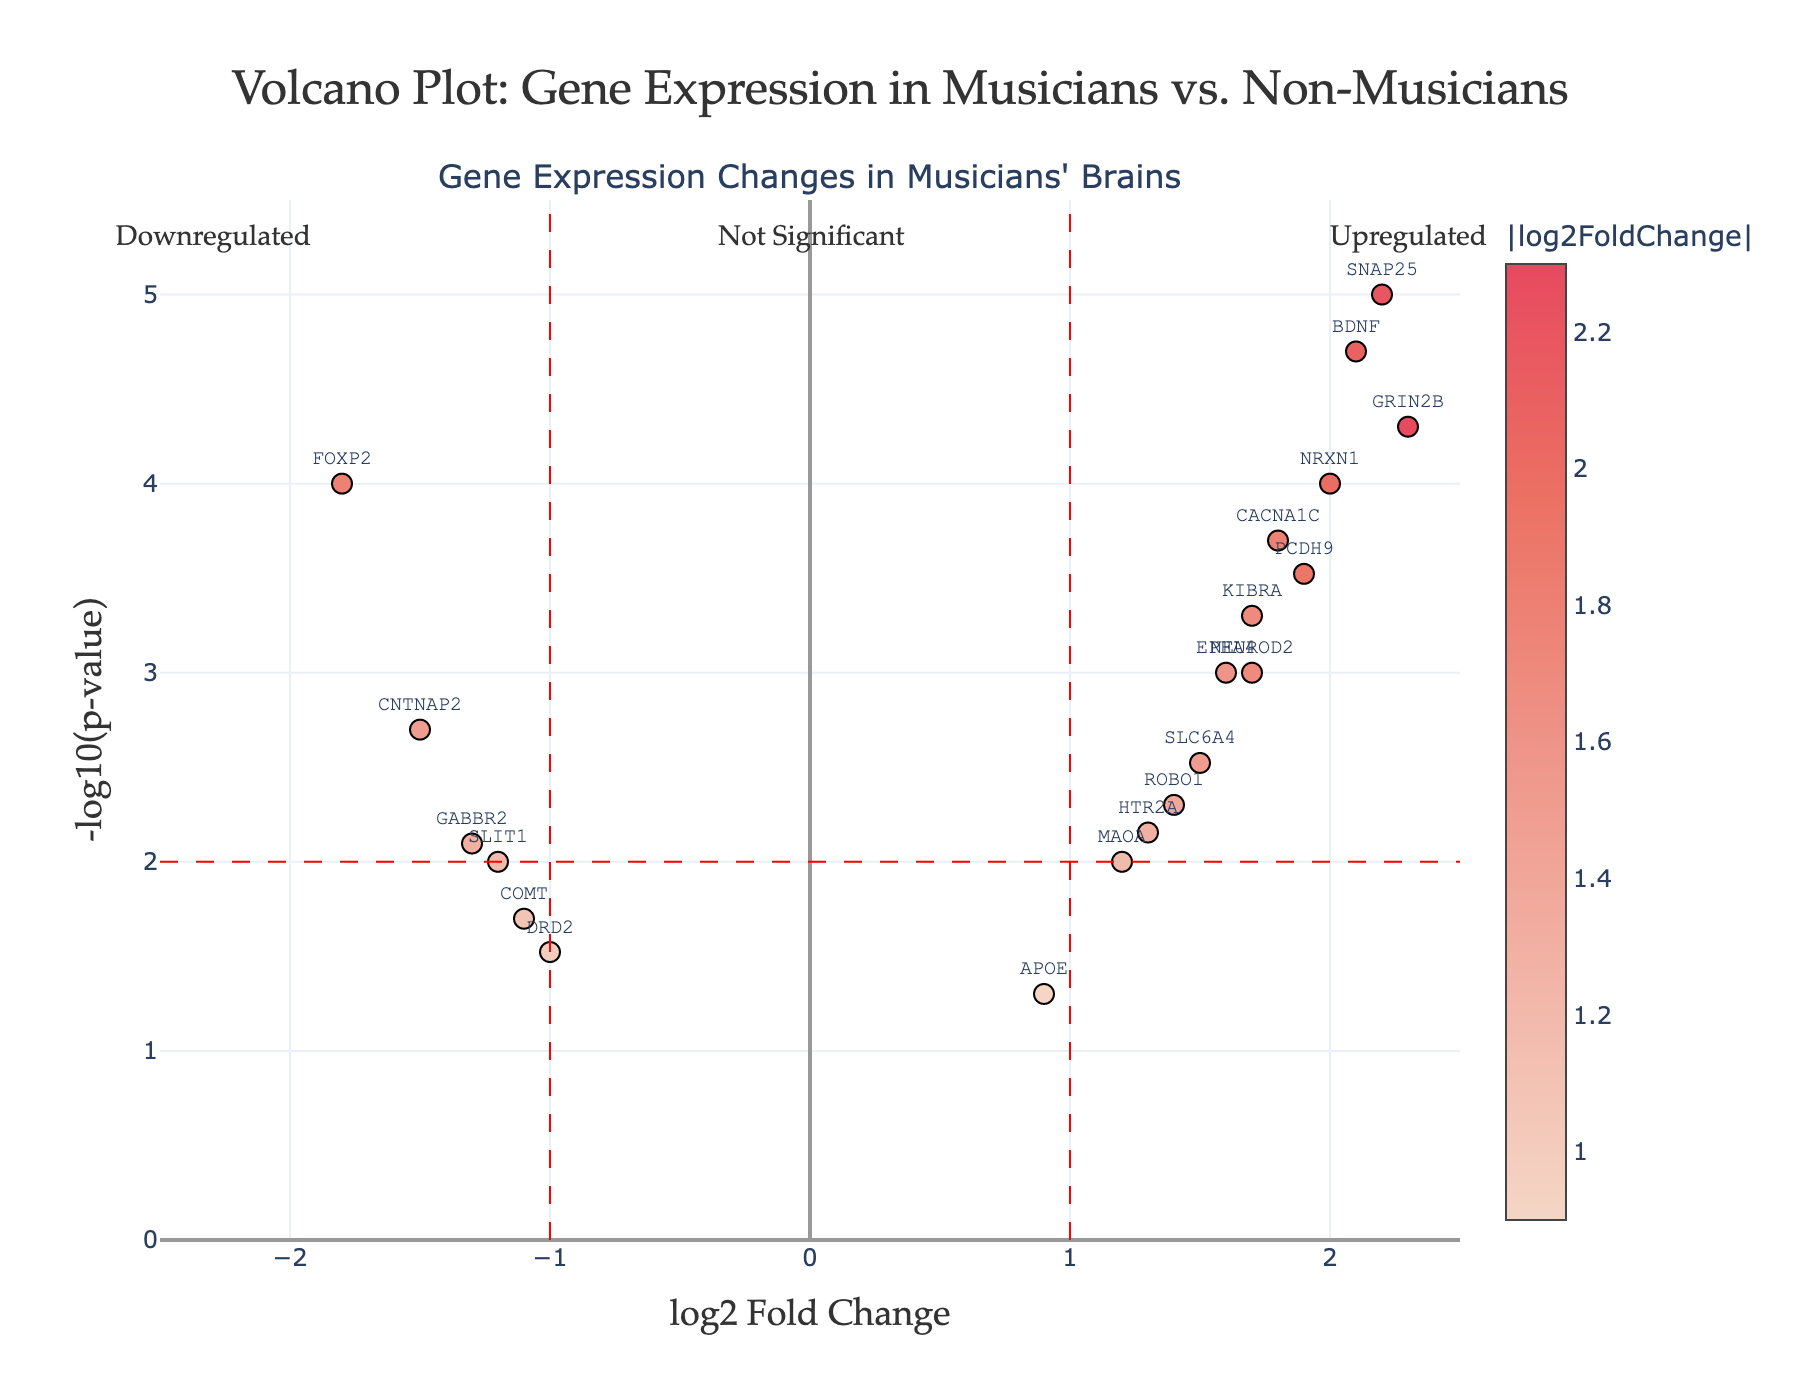How many genes have a log2 fold change greater than 2? To identify genes with a log2 fold change greater than 2, we look at the x-axis values and check for points beyond 2. The genes fitting this criterion are GRIN2B, BDNF, NRXN1, and SNAP25, so there are 4 such genes.
Answer: 4 Which gene has the highest -log10(p-value)? To find the gene with the highest -log10(p-value), we look for the point with the highest y-axis value. The highest point corresponds to the gene GRIN2B.
Answer: GRIN2B How many genes are upregulated (positive log2 fold change) and also statistically significant (p-value < 0.05)? To identify these genes, we look for points to the right of zero on the x-axis (indicating upregulation) and above the horizontal red dashed line at y=2 (-log10(0.05)). These genes are GRIN2B, NEUROD2, BDNF, PCDH9, EPHA4, ROBO1, NRXN1, CACNA1C, SLC6A4, MAOA, HTR2A, KIBRA, and SNAP25.
Answer: 13 Which genes related to fine motor skills appear downregulated (negative log2 fold change) in the plot? From a known list of genes related to fine motor skills, we identify FOXP2, CNTNAP2, and GABBR2 on the left side of the x-axis (negative log2 fold change).
Answer: FOXP2, CNTNAP2, GABBR2 What is the log2 fold change and p-value of the gene SNAP25? Hovering over the point labeled SNAP25 reveals that its log2 fold change is 2.2 and its p-value is 0.00001.
Answer: log2 fold change: 2.2, p-value: 0.00001 What does the red dashed vertical line at x = 1 represent? The red dashed vertical line at x = 1 marks the threshold separating significant upregulated genes (log2 fold change > 1) from those that are not significantly upregulated.
Answer: Threshold for significant upregulation Are there any genes that are both significantly downregulated and relevant to neurotransmitter transport? The relevant genes (FOXP2, CNTNAP2, GABBR2, COMT, DRD2) are checked if they fall on the left of x = -1 and above y = 2. FOXP2, CNTNAP2, and GABBR2 fit this criterion.
Answer: FOXP2, CNTNAP2, GABBR2 How many genes in total are presented in this plot? To find the total number of genes, count the total number of points (gene labels) displayed in the plot. There are 19 genes in the dataset provided.
Answer: 19 